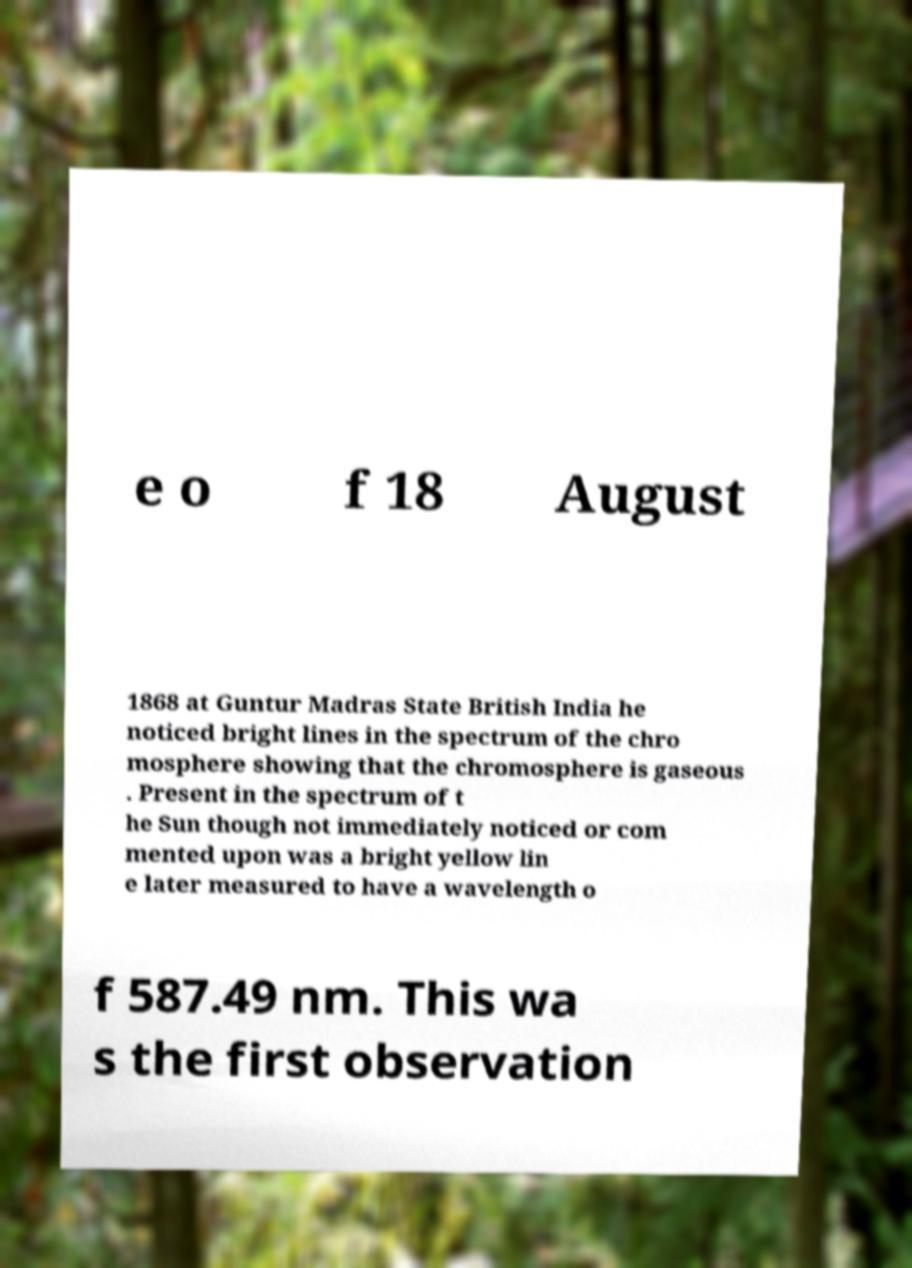Could you assist in decoding the text presented in this image and type it out clearly? e o f 18 August 1868 at Guntur Madras State British India he noticed bright lines in the spectrum of the chro mosphere showing that the chromosphere is gaseous . Present in the spectrum of t he Sun though not immediately noticed or com mented upon was a bright yellow lin e later measured to have a wavelength o f 587.49 nm. This wa s the first observation 